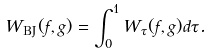<formula> <loc_0><loc_0><loc_500><loc_500>W _ { \text {BJ} } ( f , g ) = \int _ { 0 } ^ { 1 } W _ { \tau } ( f , g ) d \tau .</formula> 